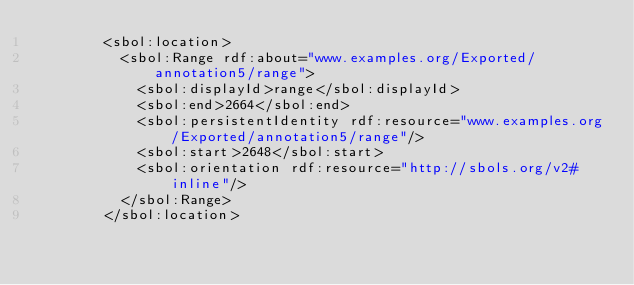<code> <loc_0><loc_0><loc_500><loc_500><_XML_>        <sbol:location>
          <sbol:Range rdf:about="www.examples.org/Exported/annotation5/range">
            <sbol:displayId>range</sbol:displayId>
            <sbol:end>2664</sbol:end>
            <sbol:persistentIdentity rdf:resource="www.examples.org/Exported/annotation5/range"/>
            <sbol:start>2648</sbol:start>
            <sbol:orientation rdf:resource="http://sbols.org/v2#inline"/>
          </sbol:Range>
        </sbol:location></code> 